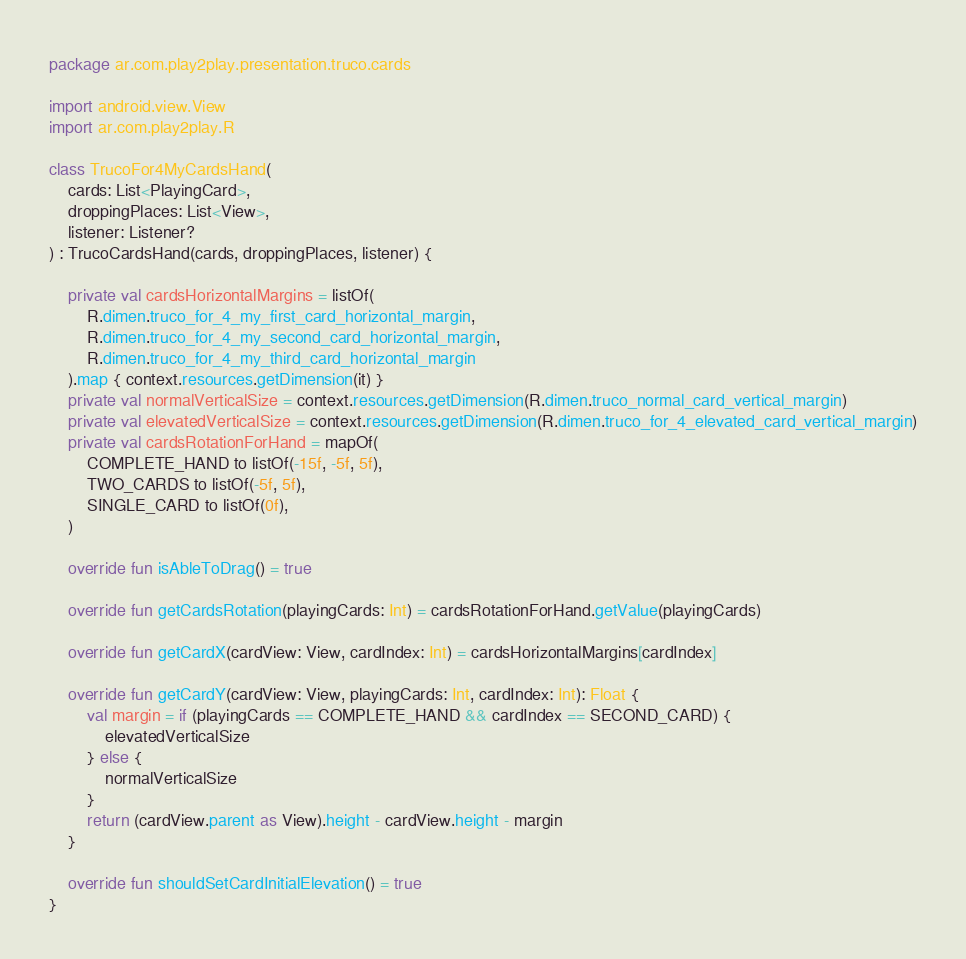<code> <loc_0><loc_0><loc_500><loc_500><_Kotlin_>package ar.com.play2play.presentation.truco.cards

import android.view.View
import ar.com.play2play.R

class TrucoFor4MyCardsHand(
    cards: List<PlayingCard>,
    droppingPlaces: List<View>,
    listener: Listener?
) : TrucoCardsHand(cards, droppingPlaces, listener) {

    private val cardsHorizontalMargins = listOf(
        R.dimen.truco_for_4_my_first_card_horizontal_margin,
        R.dimen.truco_for_4_my_second_card_horizontal_margin,
        R.dimen.truco_for_4_my_third_card_horizontal_margin
    ).map { context.resources.getDimension(it) }
    private val normalVerticalSize = context.resources.getDimension(R.dimen.truco_normal_card_vertical_margin)
    private val elevatedVerticalSize = context.resources.getDimension(R.dimen.truco_for_4_elevated_card_vertical_margin)
    private val cardsRotationForHand = mapOf(
        COMPLETE_HAND to listOf(-15f, -5f, 5f),
        TWO_CARDS to listOf(-5f, 5f),
        SINGLE_CARD to listOf(0f),
    )

    override fun isAbleToDrag() = true

    override fun getCardsRotation(playingCards: Int) = cardsRotationForHand.getValue(playingCards)

    override fun getCardX(cardView: View, cardIndex: Int) = cardsHorizontalMargins[cardIndex]

    override fun getCardY(cardView: View, playingCards: Int, cardIndex: Int): Float {
        val margin = if (playingCards == COMPLETE_HAND && cardIndex == SECOND_CARD) {
            elevatedVerticalSize
        } else {
            normalVerticalSize
        }
        return (cardView.parent as View).height - cardView.height - margin
    }

    override fun shouldSetCardInitialElevation() = true
}
</code> 